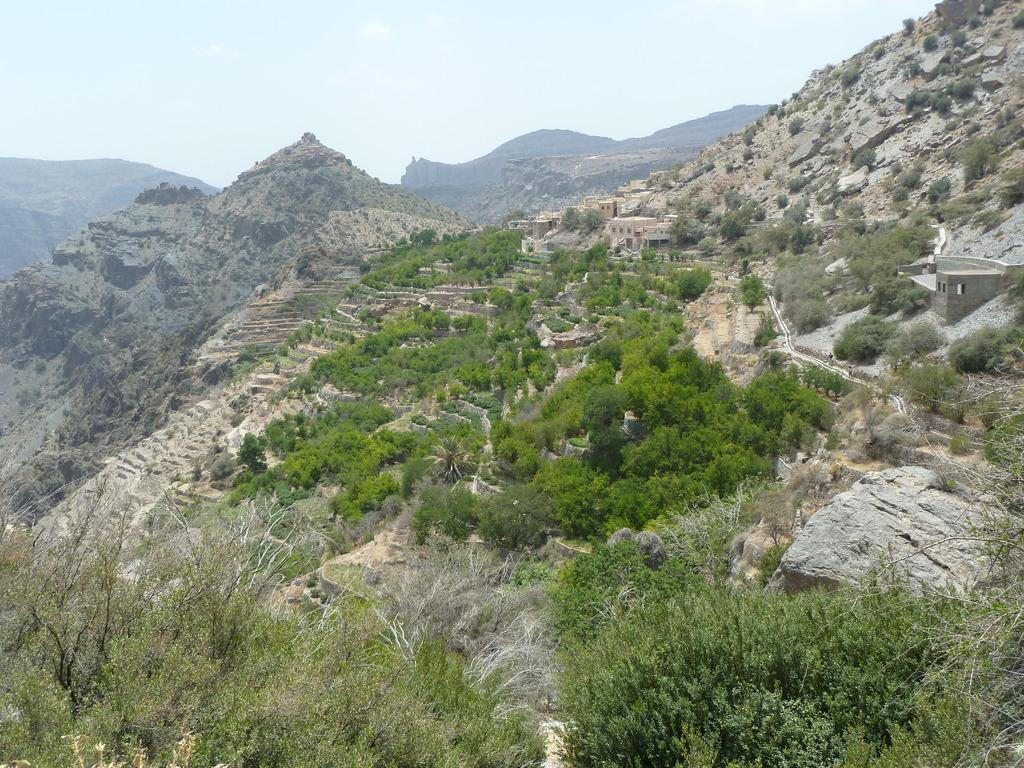What type of natural elements can be seen in the image? There are trees and rocks in the image. What type of man-made structures are present in the image? There are houses in the image. What type of geographical feature can be seen in the background of the image? There are mountains in the image. What is visible in the sky in the background of the image? The sky is visible in the background of the image. What is the name of the acoustics company featured in the image? There is no acoustics company present in the image. How does the image depict the start of a race? The image does not depict the start of a race; it features trees, rocks, houses, mountains, and the sky. 